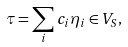<formula> <loc_0><loc_0><loc_500><loc_500>\tau = \sum _ { i } c _ { i } \eta _ { i } \in V _ { S } ,</formula> 